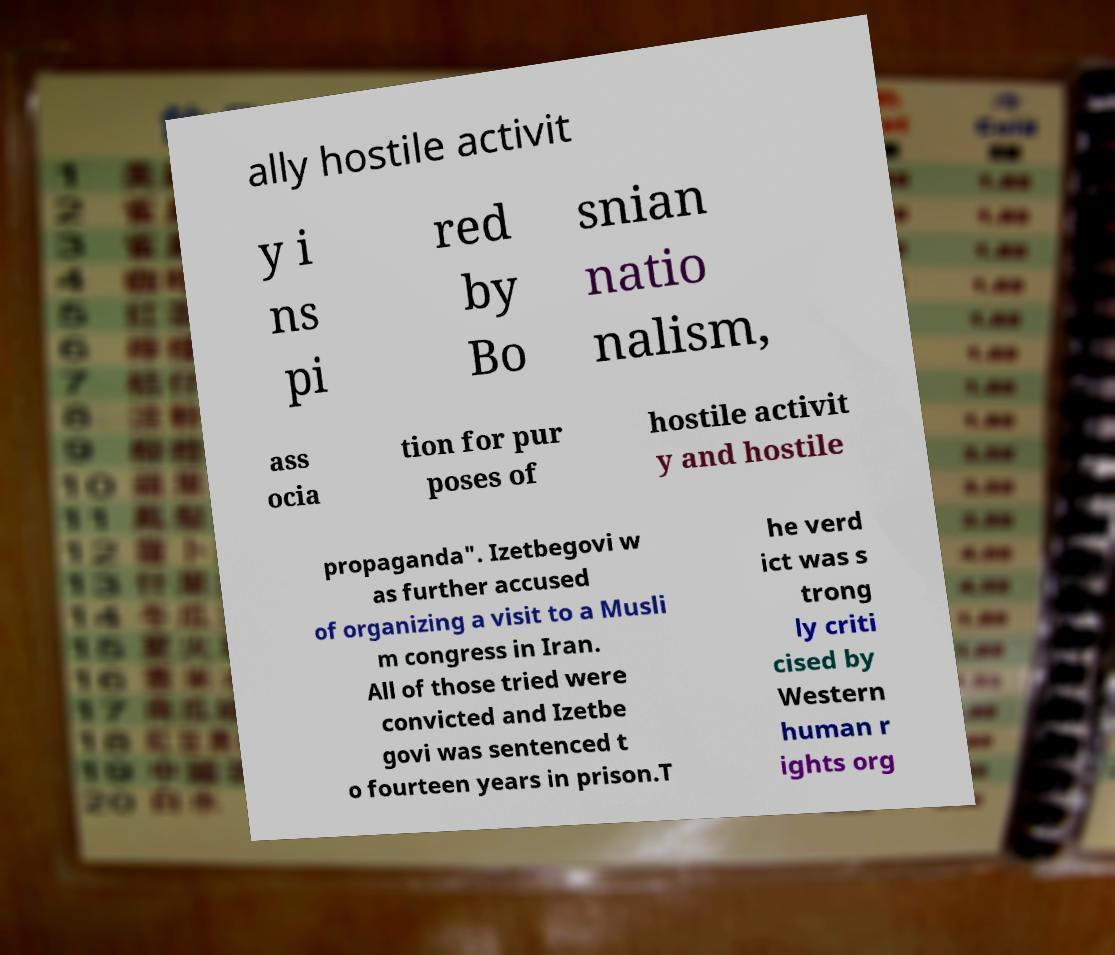For documentation purposes, I need the text within this image transcribed. Could you provide that? ally hostile activit y i ns pi red by Bo snian natio nalism, ass ocia tion for pur poses of hostile activit y and hostile propaganda". Izetbegovi w as further accused of organizing a visit to a Musli m congress in Iran. All of those tried were convicted and Izetbe govi was sentenced t o fourteen years in prison.T he verd ict was s trong ly criti cised by Western human r ights org 